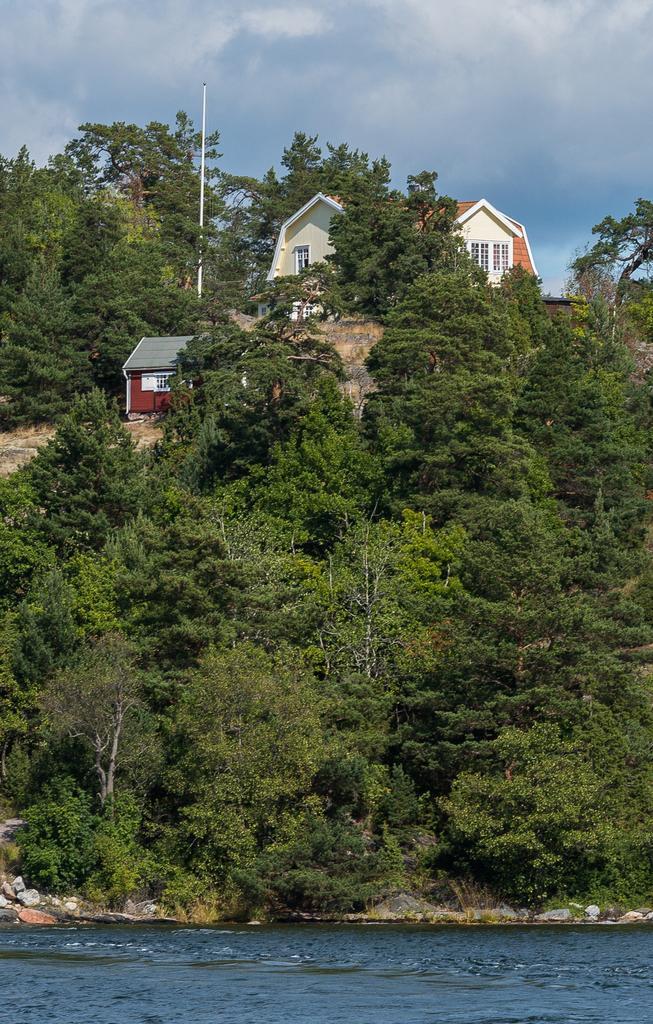Could you give a brief overview of what you see in this image? In this image, we can see trees, sheds and there is a pole. At the bottom, there is water and at the top, there are clouds in the sky. 